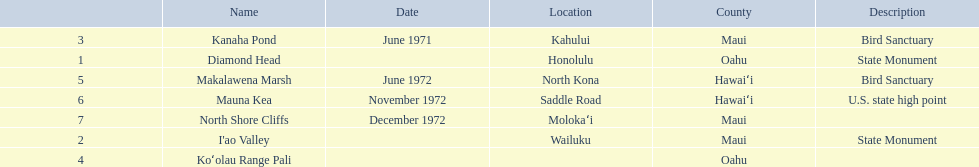What are the names of the different hawaiian national landmarks Diamond Head, I'ao Valley, Kanaha Pond, Koʻolau Range Pali, Makalawena Marsh, Mauna Kea, North Shore Cliffs. Which landmark does not have a location listed? Koʻolau Range Pali. 